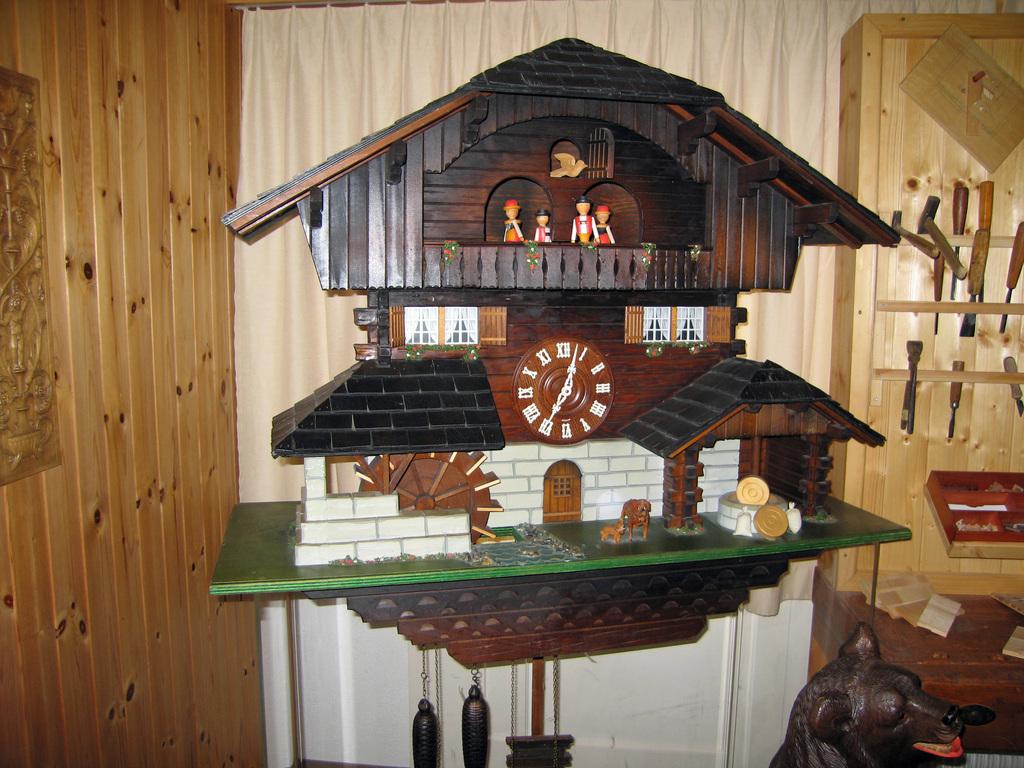What number is the minute hand of the clock currently on?
Your answer should be compact. 7. What type of numerals are on the clock?
Offer a terse response. Roman. 